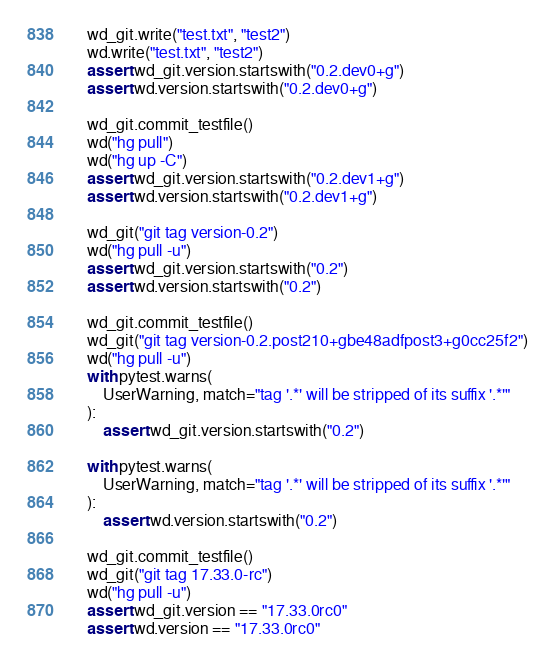Convert code to text. <code><loc_0><loc_0><loc_500><loc_500><_Python_>
    wd_git.write("test.txt", "test2")
    wd.write("test.txt", "test2")
    assert wd_git.version.startswith("0.2.dev0+g")
    assert wd.version.startswith("0.2.dev0+g")

    wd_git.commit_testfile()
    wd("hg pull")
    wd("hg up -C")
    assert wd_git.version.startswith("0.2.dev1+g")
    assert wd.version.startswith("0.2.dev1+g")

    wd_git("git tag version-0.2")
    wd("hg pull -u")
    assert wd_git.version.startswith("0.2")
    assert wd.version.startswith("0.2")

    wd_git.commit_testfile()
    wd_git("git tag version-0.2.post210+gbe48adfpost3+g0cc25f2")
    wd("hg pull -u")
    with pytest.warns(
        UserWarning, match="tag '.*' will be stripped of its suffix '.*'"
    ):
        assert wd_git.version.startswith("0.2")

    with pytest.warns(
        UserWarning, match="tag '.*' will be stripped of its suffix '.*'"
    ):
        assert wd.version.startswith("0.2")

    wd_git.commit_testfile()
    wd_git("git tag 17.33.0-rc")
    wd("hg pull -u")
    assert wd_git.version == "17.33.0rc0"
    assert wd.version == "17.33.0rc0"
</code> 